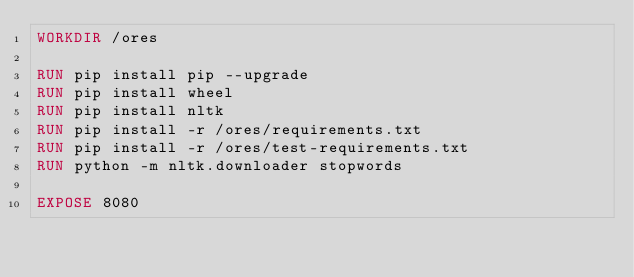<code> <loc_0><loc_0><loc_500><loc_500><_Dockerfile_>WORKDIR /ores

RUN pip install pip --upgrade
RUN pip install wheel
RUN pip install nltk
RUN pip install -r /ores/requirements.txt
RUN pip install -r /ores/test-requirements.txt
RUN python -m nltk.downloader stopwords

EXPOSE 8080
</code> 